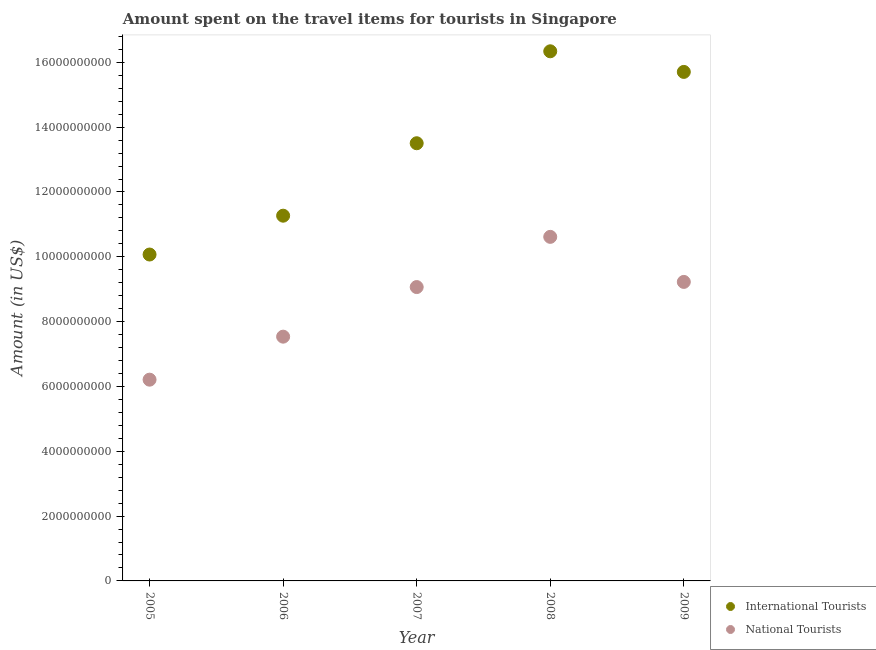How many different coloured dotlines are there?
Your answer should be very brief. 2. Is the number of dotlines equal to the number of legend labels?
Make the answer very short. Yes. What is the amount spent on travel items of international tourists in 2006?
Provide a short and direct response. 1.13e+1. Across all years, what is the maximum amount spent on travel items of national tourists?
Give a very brief answer. 1.06e+1. Across all years, what is the minimum amount spent on travel items of international tourists?
Your response must be concise. 1.01e+1. What is the total amount spent on travel items of national tourists in the graph?
Provide a succinct answer. 4.27e+1. What is the difference between the amount spent on travel items of national tourists in 2006 and that in 2007?
Provide a short and direct response. -1.53e+09. What is the difference between the amount spent on travel items of national tourists in 2007 and the amount spent on travel items of international tourists in 2009?
Give a very brief answer. -6.64e+09. What is the average amount spent on travel items of national tourists per year?
Provide a short and direct response. 8.53e+09. In the year 2006, what is the difference between the amount spent on travel items of national tourists and amount spent on travel items of international tourists?
Make the answer very short. -3.73e+09. What is the ratio of the amount spent on travel items of international tourists in 2006 to that in 2007?
Offer a terse response. 0.83. What is the difference between the highest and the second highest amount spent on travel items of international tourists?
Your response must be concise. 6.36e+08. What is the difference between the highest and the lowest amount spent on travel items of international tourists?
Offer a terse response. 6.27e+09. Is the sum of the amount spent on travel items of national tourists in 2005 and 2008 greater than the maximum amount spent on travel items of international tourists across all years?
Ensure brevity in your answer.  Yes. How many years are there in the graph?
Keep it short and to the point. 5. What is the difference between two consecutive major ticks on the Y-axis?
Offer a very short reply. 2.00e+09. Are the values on the major ticks of Y-axis written in scientific E-notation?
Offer a very short reply. No. Does the graph contain any zero values?
Keep it short and to the point. No. Where does the legend appear in the graph?
Keep it short and to the point. Bottom right. What is the title of the graph?
Make the answer very short. Amount spent on the travel items for tourists in Singapore. Does "Number of arrivals" appear as one of the legend labels in the graph?
Provide a short and direct response. No. What is the label or title of the X-axis?
Your answer should be compact. Year. What is the Amount (in US$) of International Tourists in 2005?
Your answer should be very brief. 1.01e+1. What is the Amount (in US$) in National Tourists in 2005?
Your answer should be very brief. 6.21e+09. What is the Amount (in US$) of International Tourists in 2006?
Provide a succinct answer. 1.13e+1. What is the Amount (in US$) in National Tourists in 2006?
Offer a very short reply. 7.54e+09. What is the Amount (in US$) in International Tourists in 2007?
Offer a very short reply. 1.35e+1. What is the Amount (in US$) of National Tourists in 2007?
Offer a terse response. 9.07e+09. What is the Amount (in US$) of International Tourists in 2008?
Offer a very short reply. 1.63e+1. What is the Amount (in US$) in National Tourists in 2008?
Ensure brevity in your answer.  1.06e+1. What is the Amount (in US$) in International Tourists in 2009?
Offer a terse response. 1.57e+1. What is the Amount (in US$) in National Tourists in 2009?
Ensure brevity in your answer.  9.22e+09. Across all years, what is the maximum Amount (in US$) in International Tourists?
Offer a terse response. 1.63e+1. Across all years, what is the maximum Amount (in US$) of National Tourists?
Provide a succinct answer. 1.06e+1. Across all years, what is the minimum Amount (in US$) of International Tourists?
Your answer should be very brief. 1.01e+1. Across all years, what is the minimum Amount (in US$) of National Tourists?
Offer a very short reply. 6.21e+09. What is the total Amount (in US$) of International Tourists in the graph?
Provide a short and direct response. 6.69e+1. What is the total Amount (in US$) of National Tourists in the graph?
Your response must be concise. 4.27e+1. What is the difference between the Amount (in US$) in International Tourists in 2005 and that in 2006?
Offer a very short reply. -1.20e+09. What is the difference between the Amount (in US$) in National Tourists in 2005 and that in 2006?
Offer a very short reply. -1.33e+09. What is the difference between the Amount (in US$) of International Tourists in 2005 and that in 2007?
Make the answer very short. -3.43e+09. What is the difference between the Amount (in US$) in National Tourists in 2005 and that in 2007?
Your answer should be compact. -2.86e+09. What is the difference between the Amount (in US$) in International Tourists in 2005 and that in 2008?
Make the answer very short. -6.27e+09. What is the difference between the Amount (in US$) of National Tourists in 2005 and that in 2008?
Your answer should be compact. -4.41e+09. What is the difference between the Amount (in US$) in International Tourists in 2005 and that in 2009?
Make the answer very short. -5.63e+09. What is the difference between the Amount (in US$) of National Tourists in 2005 and that in 2009?
Provide a succinct answer. -3.02e+09. What is the difference between the Amount (in US$) of International Tourists in 2006 and that in 2007?
Offer a terse response. -2.24e+09. What is the difference between the Amount (in US$) of National Tourists in 2006 and that in 2007?
Ensure brevity in your answer.  -1.53e+09. What is the difference between the Amount (in US$) of International Tourists in 2006 and that in 2008?
Keep it short and to the point. -5.07e+09. What is the difference between the Amount (in US$) of National Tourists in 2006 and that in 2008?
Provide a succinct answer. -3.08e+09. What is the difference between the Amount (in US$) in International Tourists in 2006 and that in 2009?
Make the answer very short. -4.44e+09. What is the difference between the Amount (in US$) of National Tourists in 2006 and that in 2009?
Provide a succinct answer. -1.69e+09. What is the difference between the Amount (in US$) in International Tourists in 2007 and that in 2008?
Your response must be concise. -2.84e+09. What is the difference between the Amount (in US$) of National Tourists in 2007 and that in 2008?
Keep it short and to the point. -1.55e+09. What is the difference between the Amount (in US$) of International Tourists in 2007 and that in 2009?
Your answer should be compact. -2.20e+09. What is the difference between the Amount (in US$) in National Tourists in 2007 and that in 2009?
Provide a short and direct response. -1.59e+08. What is the difference between the Amount (in US$) in International Tourists in 2008 and that in 2009?
Your answer should be compact. 6.36e+08. What is the difference between the Amount (in US$) of National Tourists in 2008 and that in 2009?
Your response must be concise. 1.39e+09. What is the difference between the Amount (in US$) of International Tourists in 2005 and the Amount (in US$) of National Tourists in 2006?
Offer a very short reply. 2.53e+09. What is the difference between the Amount (in US$) in International Tourists in 2005 and the Amount (in US$) in National Tourists in 2007?
Your answer should be compact. 1.00e+09. What is the difference between the Amount (in US$) of International Tourists in 2005 and the Amount (in US$) of National Tourists in 2008?
Your answer should be compact. -5.45e+08. What is the difference between the Amount (in US$) of International Tourists in 2005 and the Amount (in US$) of National Tourists in 2009?
Keep it short and to the point. 8.45e+08. What is the difference between the Amount (in US$) in International Tourists in 2006 and the Amount (in US$) in National Tourists in 2007?
Offer a terse response. 2.20e+09. What is the difference between the Amount (in US$) in International Tourists in 2006 and the Amount (in US$) in National Tourists in 2008?
Provide a short and direct response. 6.53e+08. What is the difference between the Amount (in US$) of International Tourists in 2006 and the Amount (in US$) of National Tourists in 2009?
Provide a succinct answer. 2.04e+09. What is the difference between the Amount (in US$) of International Tourists in 2007 and the Amount (in US$) of National Tourists in 2008?
Make the answer very short. 2.89e+09. What is the difference between the Amount (in US$) of International Tourists in 2007 and the Amount (in US$) of National Tourists in 2009?
Provide a short and direct response. 4.28e+09. What is the difference between the Amount (in US$) of International Tourists in 2008 and the Amount (in US$) of National Tourists in 2009?
Provide a short and direct response. 7.12e+09. What is the average Amount (in US$) in International Tourists per year?
Make the answer very short. 1.34e+1. What is the average Amount (in US$) in National Tourists per year?
Keep it short and to the point. 8.53e+09. In the year 2005, what is the difference between the Amount (in US$) in International Tourists and Amount (in US$) in National Tourists?
Your answer should be very brief. 3.86e+09. In the year 2006, what is the difference between the Amount (in US$) in International Tourists and Amount (in US$) in National Tourists?
Keep it short and to the point. 3.73e+09. In the year 2007, what is the difference between the Amount (in US$) of International Tourists and Amount (in US$) of National Tourists?
Your answer should be compact. 4.44e+09. In the year 2008, what is the difference between the Amount (in US$) in International Tourists and Amount (in US$) in National Tourists?
Keep it short and to the point. 5.72e+09. In the year 2009, what is the difference between the Amount (in US$) in International Tourists and Amount (in US$) in National Tourists?
Keep it short and to the point. 6.48e+09. What is the ratio of the Amount (in US$) of International Tourists in 2005 to that in 2006?
Your answer should be compact. 0.89. What is the ratio of the Amount (in US$) in National Tourists in 2005 to that in 2006?
Provide a succinct answer. 0.82. What is the ratio of the Amount (in US$) in International Tourists in 2005 to that in 2007?
Provide a succinct answer. 0.75. What is the ratio of the Amount (in US$) of National Tourists in 2005 to that in 2007?
Ensure brevity in your answer.  0.68. What is the ratio of the Amount (in US$) in International Tourists in 2005 to that in 2008?
Offer a very short reply. 0.62. What is the ratio of the Amount (in US$) of National Tourists in 2005 to that in 2008?
Your answer should be very brief. 0.58. What is the ratio of the Amount (in US$) of International Tourists in 2005 to that in 2009?
Keep it short and to the point. 0.64. What is the ratio of the Amount (in US$) in National Tourists in 2005 to that in 2009?
Keep it short and to the point. 0.67. What is the ratio of the Amount (in US$) in International Tourists in 2006 to that in 2007?
Your answer should be compact. 0.83. What is the ratio of the Amount (in US$) in National Tourists in 2006 to that in 2007?
Offer a terse response. 0.83. What is the ratio of the Amount (in US$) of International Tourists in 2006 to that in 2008?
Provide a succinct answer. 0.69. What is the ratio of the Amount (in US$) of National Tourists in 2006 to that in 2008?
Make the answer very short. 0.71. What is the ratio of the Amount (in US$) of International Tourists in 2006 to that in 2009?
Ensure brevity in your answer.  0.72. What is the ratio of the Amount (in US$) in National Tourists in 2006 to that in 2009?
Your answer should be compact. 0.82. What is the ratio of the Amount (in US$) of International Tourists in 2007 to that in 2008?
Provide a succinct answer. 0.83. What is the ratio of the Amount (in US$) in National Tourists in 2007 to that in 2008?
Make the answer very short. 0.85. What is the ratio of the Amount (in US$) of International Tourists in 2007 to that in 2009?
Ensure brevity in your answer.  0.86. What is the ratio of the Amount (in US$) of National Tourists in 2007 to that in 2009?
Your response must be concise. 0.98. What is the ratio of the Amount (in US$) in International Tourists in 2008 to that in 2009?
Provide a succinct answer. 1.04. What is the ratio of the Amount (in US$) in National Tourists in 2008 to that in 2009?
Provide a short and direct response. 1.15. What is the difference between the highest and the second highest Amount (in US$) in International Tourists?
Give a very brief answer. 6.36e+08. What is the difference between the highest and the second highest Amount (in US$) in National Tourists?
Your answer should be compact. 1.39e+09. What is the difference between the highest and the lowest Amount (in US$) of International Tourists?
Offer a very short reply. 6.27e+09. What is the difference between the highest and the lowest Amount (in US$) in National Tourists?
Provide a short and direct response. 4.41e+09. 